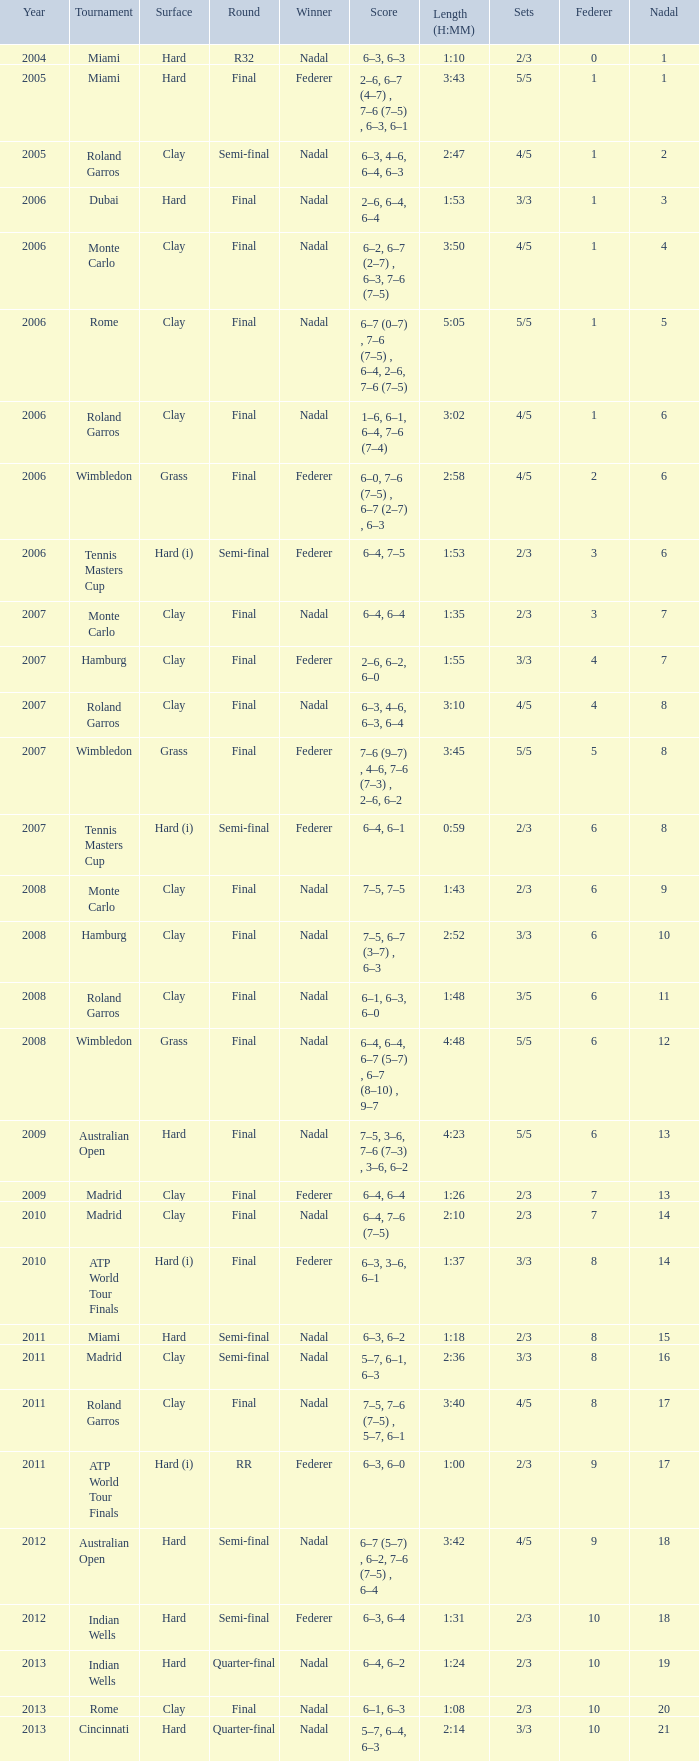What were the sets when Federer had 6 and a nadal of 13? 5/5. 